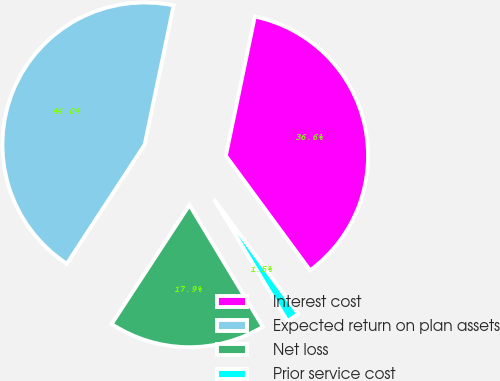Convert chart. <chart><loc_0><loc_0><loc_500><loc_500><pie_chart><fcel>Interest cost<fcel>Expected return on plan assets<fcel>Net loss<fcel>Prior service cost<nl><fcel>36.64%<fcel>44.05%<fcel>17.85%<fcel>1.46%<nl></chart> 